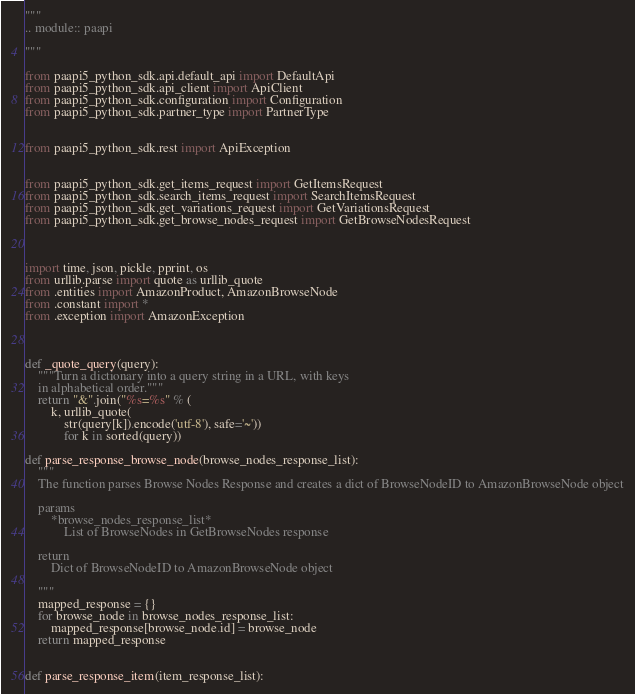<code> <loc_0><loc_0><loc_500><loc_500><_Python_>"""
.. module:: paapi

"""

from paapi5_python_sdk.api.default_api import DefaultApi
from paapi5_python_sdk.api_client import ApiClient
from paapi5_python_sdk.configuration import Configuration
from paapi5_python_sdk.partner_type import PartnerType


from paapi5_python_sdk.rest import ApiException


from paapi5_python_sdk.get_items_request import GetItemsRequest
from paapi5_python_sdk.search_items_request import SearchItemsRequest
from paapi5_python_sdk.get_variations_request import GetVariationsRequest
from paapi5_python_sdk.get_browse_nodes_request import GetBrowseNodesRequest



import time, json, pickle, pprint, os
from urllib.parse import quote as urllib_quote
from .entities import AmazonProduct, AmazonBrowseNode
from .constant import *
from .exception import AmazonException



def _quote_query(query):
    """Turn a dictionary into a query string in a URL, with keys
    in alphabetical order."""
    return "&".join("%s=%s" % (
        k, urllib_quote(
            str(query[k]).encode('utf-8'), safe='~'))
            for k in sorted(query))

def parse_response_browse_node(browse_nodes_response_list):
    """
    The function parses Browse Nodes Response and creates a dict of BrowseNodeID to AmazonBrowseNode object

    params
        *browse_nodes_response_list*
            List of BrowseNodes in GetBrowseNodes response

    return
        Dict of BrowseNodeID to AmazonBrowseNode object

    """
    mapped_response = {}
    for browse_node in browse_nodes_response_list:
        mapped_response[browse_node.id] = browse_node
    return mapped_response


def parse_response_item(item_response_list):</code> 